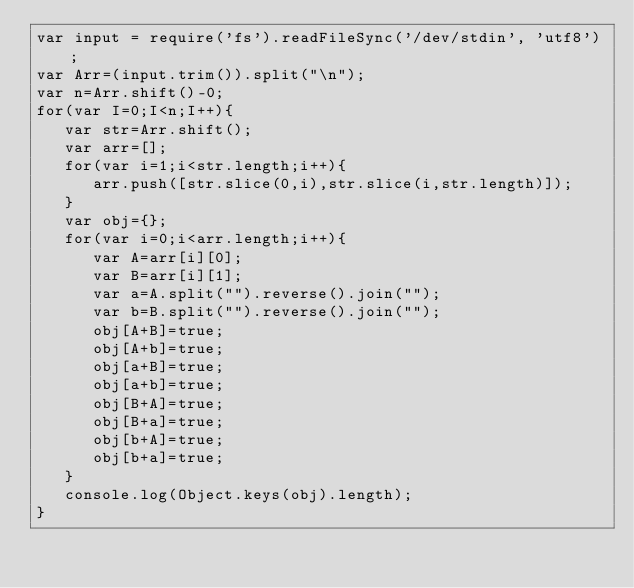Convert code to text. <code><loc_0><loc_0><loc_500><loc_500><_JavaScript_>var input = require('fs').readFileSync('/dev/stdin', 'utf8');
var Arr=(input.trim()).split("\n");
var n=Arr.shift()-0;
for(var I=0;I<n;I++){
   var str=Arr.shift();
   var arr=[];
   for(var i=1;i<str.length;i++){
      arr.push([str.slice(0,i),str.slice(i,str.length)]);
   }
   var obj={};
   for(var i=0;i<arr.length;i++){
      var A=arr[i][0];
      var B=arr[i][1];
      var a=A.split("").reverse().join("");
      var b=B.split("").reverse().join("");
      obj[A+B]=true;
      obj[A+b]=true;
      obj[a+B]=true;
      obj[a+b]=true;
      obj[B+A]=true;
      obj[B+a]=true;
      obj[b+A]=true;
      obj[b+a]=true;
   }
   console.log(Object.keys(obj).length);
}</code> 